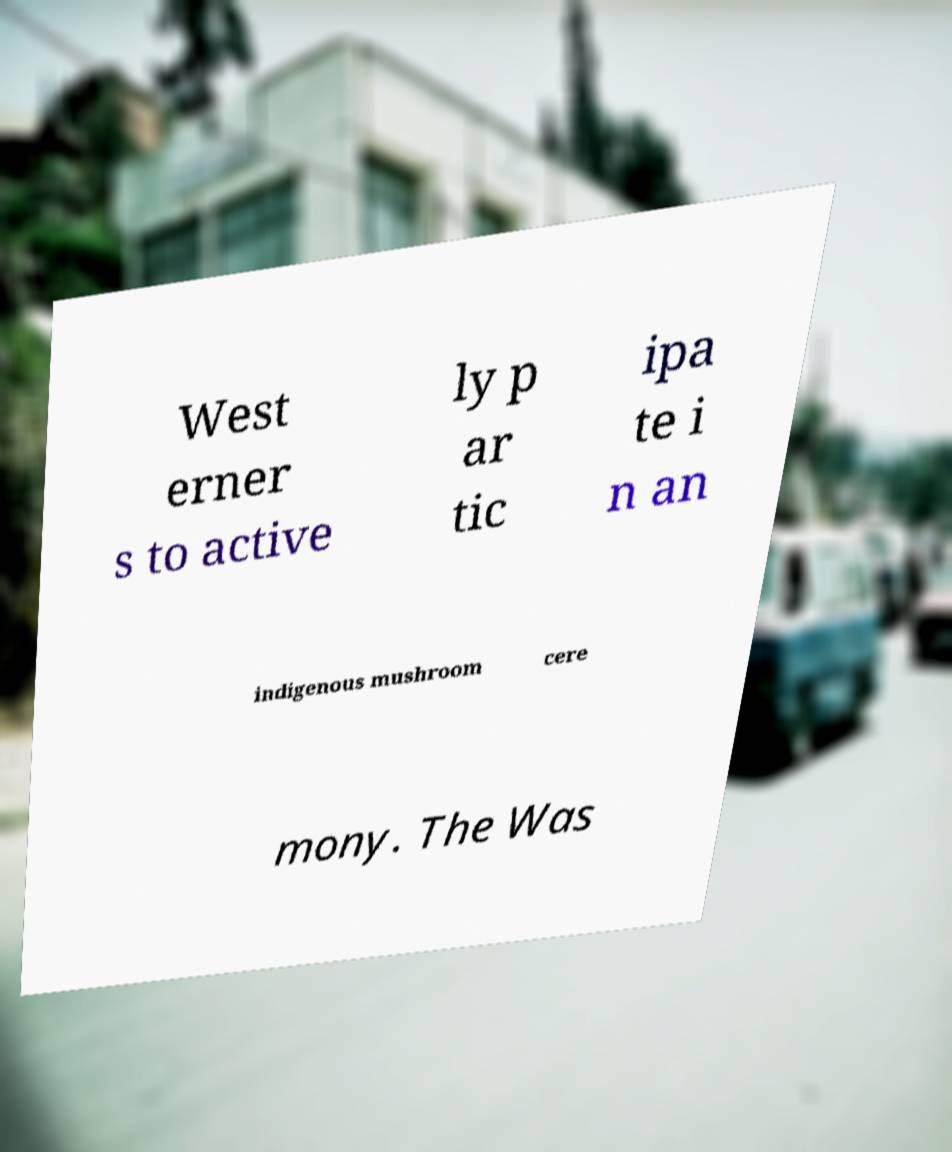Can you read and provide the text displayed in the image?This photo seems to have some interesting text. Can you extract and type it out for me? West erner s to active ly p ar tic ipa te i n an indigenous mushroom cere mony. The Was 